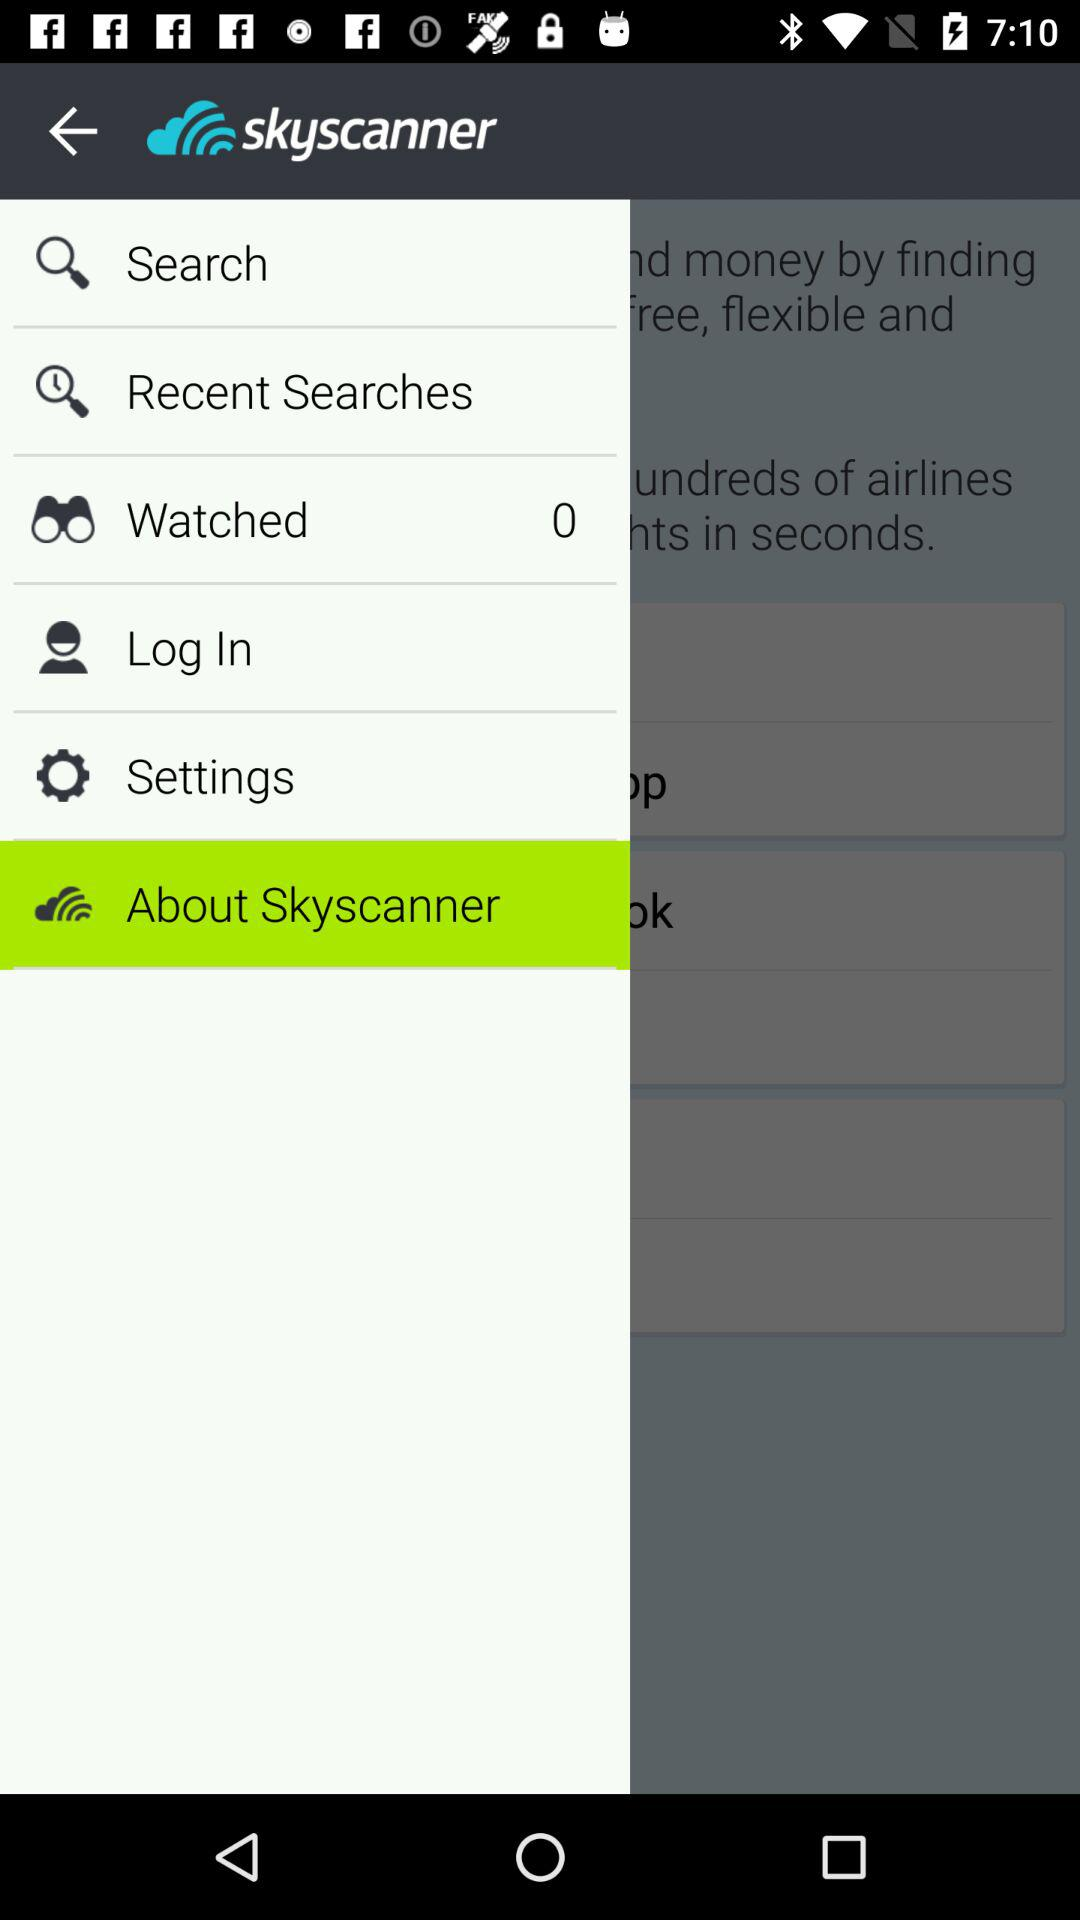What is listed in recent searches?
When the provided information is insufficient, respond with <no answer>. <no answer> 